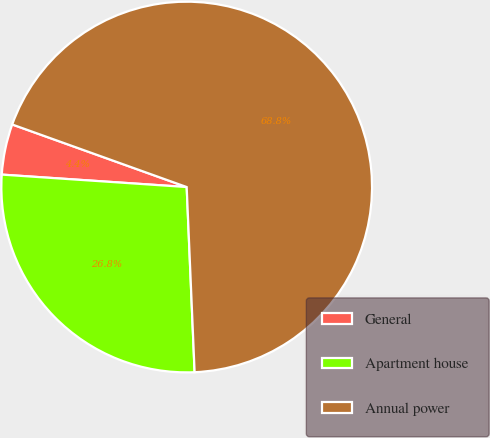Convert chart to OTSL. <chart><loc_0><loc_0><loc_500><loc_500><pie_chart><fcel>General<fcel>Apartment house<fcel>Annual power<nl><fcel>4.41%<fcel>26.75%<fcel>68.84%<nl></chart> 